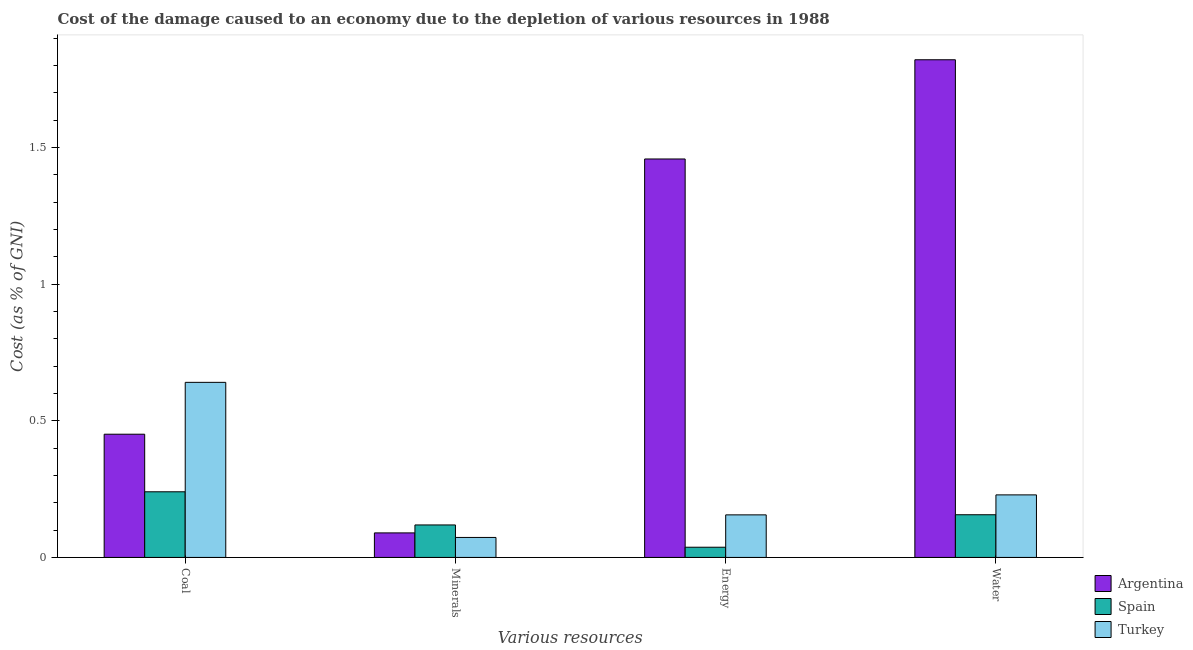Are the number of bars per tick equal to the number of legend labels?
Make the answer very short. Yes. Are the number of bars on each tick of the X-axis equal?
Provide a succinct answer. Yes. What is the label of the 4th group of bars from the left?
Ensure brevity in your answer.  Water. What is the cost of damage due to depletion of energy in Argentina?
Provide a succinct answer. 1.46. Across all countries, what is the maximum cost of damage due to depletion of energy?
Provide a short and direct response. 1.46. Across all countries, what is the minimum cost of damage due to depletion of water?
Provide a succinct answer. 0.16. In which country was the cost of damage due to depletion of energy maximum?
Keep it short and to the point. Argentina. What is the total cost of damage due to depletion of coal in the graph?
Provide a succinct answer. 1.33. What is the difference between the cost of damage due to depletion of coal in Turkey and that in Spain?
Ensure brevity in your answer.  0.4. What is the difference between the cost of damage due to depletion of water in Spain and the cost of damage due to depletion of energy in Turkey?
Give a very brief answer. 0. What is the average cost of damage due to depletion of minerals per country?
Keep it short and to the point. 0.09. What is the difference between the cost of damage due to depletion of coal and cost of damage due to depletion of water in Argentina?
Make the answer very short. -1.37. What is the ratio of the cost of damage due to depletion of energy in Argentina to that in Turkey?
Your answer should be very brief. 9.36. Is the cost of damage due to depletion of minerals in Turkey less than that in Spain?
Ensure brevity in your answer.  Yes. What is the difference between the highest and the second highest cost of damage due to depletion of coal?
Offer a terse response. 0.19. What is the difference between the highest and the lowest cost of damage due to depletion of minerals?
Offer a terse response. 0.05. Is the sum of the cost of damage due to depletion of energy in Spain and Argentina greater than the maximum cost of damage due to depletion of water across all countries?
Make the answer very short. No. Is it the case that in every country, the sum of the cost of damage due to depletion of minerals and cost of damage due to depletion of energy is greater than the sum of cost of damage due to depletion of coal and cost of damage due to depletion of water?
Offer a terse response. No. What does the 3rd bar from the right in Minerals represents?
Offer a very short reply. Argentina. How many bars are there?
Make the answer very short. 12. Does the graph contain any zero values?
Your answer should be compact. No. How are the legend labels stacked?
Offer a very short reply. Vertical. What is the title of the graph?
Your answer should be very brief. Cost of the damage caused to an economy due to the depletion of various resources in 1988 . Does "Venezuela" appear as one of the legend labels in the graph?
Offer a terse response. No. What is the label or title of the X-axis?
Keep it short and to the point. Various resources. What is the label or title of the Y-axis?
Offer a terse response. Cost (as % of GNI). What is the Cost (as % of GNI) in Argentina in Coal?
Offer a terse response. 0.45. What is the Cost (as % of GNI) in Spain in Coal?
Offer a terse response. 0.24. What is the Cost (as % of GNI) in Turkey in Coal?
Ensure brevity in your answer.  0.64. What is the Cost (as % of GNI) of Argentina in Minerals?
Make the answer very short. 0.09. What is the Cost (as % of GNI) of Spain in Minerals?
Offer a terse response. 0.12. What is the Cost (as % of GNI) of Turkey in Minerals?
Ensure brevity in your answer.  0.07. What is the Cost (as % of GNI) in Argentina in Energy?
Provide a short and direct response. 1.46. What is the Cost (as % of GNI) of Spain in Energy?
Provide a succinct answer. 0.04. What is the Cost (as % of GNI) in Turkey in Energy?
Your answer should be very brief. 0.16. What is the Cost (as % of GNI) in Argentina in Water?
Provide a short and direct response. 1.82. What is the Cost (as % of GNI) of Spain in Water?
Your response must be concise. 0.16. What is the Cost (as % of GNI) of Turkey in Water?
Keep it short and to the point. 0.23. Across all Various resources, what is the maximum Cost (as % of GNI) of Argentina?
Give a very brief answer. 1.82. Across all Various resources, what is the maximum Cost (as % of GNI) in Spain?
Provide a succinct answer. 0.24. Across all Various resources, what is the maximum Cost (as % of GNI) of Turkey?
Offer a very short reply. 0.64. Across all Various resources, what is the minimum Cost (as % of GNI) of Argentina?
Provide a succinct answer. 0.09. Across all Various resources, what is the minimum Cost (as % of GNI) of Spain?
Your response must be concise. 0.04. Across all Various resources, what is the minimum Cost (as % of GNI) in Turkey?
Give a very brief answer. 0.07. What is the total Cost (as % of GNI) of Argentina in the graph?
Give a very brief answer. 3.82. What is the total Cost (as % of GNI) in Spain in the graph?
Keep it short and to the point. 0.55. What is the total Cost (as % of GNI) of Turkey in the graph?
Provide a succinct answer. 1.1. What is the difference between the Cost (as % of GNI) in Argentina in Coal and that in Minerals?
Ensure brevity in your answer.  0.36. What is the difference between the Cost (as % of GNI) of Spain in Coal and that in Minerals?
Your answer should be compact. 0.12. What is the difference between the Cost (as % of GNI) in Turkey in Coal and that in Minerals?
Offer a very short reply. 0.57. What is the difference between the Cost (as % of GNI) in Argentina in Coal and that in Energy?
Your response must be concise. -1.01. What is the difference between the Cost (as % of GNI) in Spain in Coal and that in Energy?
Ensure brevity in your answer.  0.2. What is the difference between the Cost (as % of GNI) of Turkey in Coal and that in Energy?
Keep it short and to the point. 0.48. What is the difference between the Cost (as % of GNI) in Argentina in Coal and that in Water?
Provide a succinct answer. -1.37. What is the difference between the Cost (as % of GNI) in Spain in Coal and that in Water?
Your answer should be very brief. 0.08. What is the difference between the Cost (as % of GNI) of Turkey in Coal and that in Water?
Offer a terse response. 0.41. What is the difference between the Cost (as % of GNI) of Argentina in Minerals and that in Energy?
Offer a terse response. -1.37. What is the difference between the Cost (as % of GNI) of Spain in Minerals and that in Energy?
Offer a terse response. 0.08. What is the difference between the Cost (as % of GNI) in Turkey in Minerals and that in Energy?
Make the answer very short. -0.08. What is the difference between the Cost (as % of GNI) of Argentina in Minerals and that in Water?
Ensure brevity in your answer.  -1.73. What is the difference between the Cost (as % of GNI) of Spain in Minerals and that in Water?
Your answer should be compact. -0.04. What is the difference between the Cost (as % of GNI) in Turkey in Minerals and that in Water?
Ensure brevity in your answer.  -0.16. What is the difference between the Cost (as % of GNI) of Argentina in Energy and that in Water?
Make the answer very short. -0.36. What is the difference between the Cost (as % of GNI) in Spain in Energy and that in Water?
Offer a terse response. -0.12. What is the difference between the Cost (as % of GNI) in Turkey in Energy and that in Water?
Offer a terse response. -0.07. What is the difference between the Cost (as % of GNI) of Argentina in Coal and the Cost (as % of GNI) of Spain in Minerals?
Make the answer very short. 0.33. What is the difference between the Cost (as % of GNI) in Argentina in Coal and the Cost (as % of GNI) in Turkey in Minerals?
Your answer should be compact. 0.38. What is the difference between the Cost (as % of GNI) in Spain in Coal and the Cost (as % of GNI) in Turkey in Minerals?
Your response must be concise. 0.17. What is the difference between the Cost (as % of GNI) of Argentina in Coal and the Cost (as % of GNI) of Spain in Energy?
Provide a succinct answer. 0.41. What is the difference between the Cost (as % of GNI) in Argentina in Coal and the Cost (as % of GNI) in Turkey in Energy?
Your answer should be compact. 0.3. What is the difference between the Cost (as % of GNI) in Spain in Coal and the Cost (as % of GNI) in Turkey in Energy?
Provide a succinct answer. 0.08. What is the difference between the Cost (as % of GNI) of Argentina in Coal and the Cost (as % of GNI) of Spain in Water?
Provide a short and direct response. 0.29. What is the difference between the Cost (as % of GNI) in Argentina in Coal and the Cost (as % of GNI) in Turkey in Water?
Provide a succinct answer. 0.22. What is the difference between the Cost (as % of GNI) of Spain in Coal and the Cost (as % of GNI) of Turkey in Water?
Give a very brief answer. 0.01. What is the difference between the Cost (as % of GNI) in Argentina in Minerals and the Cost (as % of GNI) in Spain in Energy?
Give a very brief answer. 0.05. What is the difference between the Cost (as % of GNI) of Argentina in Minerals and the Cost (as % of GNI) of Turkey in Energy?
Your response must be concise. -0.07. What is the difference between the Cost (as % of GNI) of Spain in Minerals and the Cost (as % of GNI) of Turkey in Energy?
Your response must be concise. -0.04. What is the difference between the Cost (as % of GNI) of Argentina in Minerals and the Cost (as % of GNI) of Spain in Water?
Keep it short and to the point. -0.07. What is the difference between the Cost (as % of GNI) in Argentina in Minerals and the Cost (as % of GNI) in Turkey in Water?
Your answer should be very brief. -0.14. What is the difference between the Cost (as % of GNI) in Spain in Minerals and the Cost (as % of GNI) in Turkey in Water?
Keep it short and to the point. -0.11. What is the difference between the Cost (as % of GNI) of Argentina in Energy and the Cost (as % of GNI) of Spain in Water?
Your answer should be compact. 1.3. What is the difference between the Cost (as % of GNI) in Argentina in Energy and the Cost (as % of GNI) in Turkey in Water?
Your answer should be compact. 1.23. What is the difference between the Cost (as % of GNI) in Spain in Energy and the Cost (as % of GNI) in Turkey in Water?
Your response must be concise. -0.19. What is the average Cost (as % of GNI) of Argentina per Various resources?
Keep it short and to the point. 0.95. What is the average Cost (as % of GNI) of Spain per Various resources?
Provide a succinct answer. 0.14. What is the average Cost (as % of GNI) in Turkey per Various resources?
Ensure brevity in your answer.  0.27. What is the difference between the Cost (as % of GNI) of Argentina and Cost (as % of GNI) of Spain in Coal?
Your answer should be very brief. 0.21. What is the difference between the Cost (as % of GNI) of Argentina and Cost (as % of GNI) of Turkey in Coal?
Your answer should be compact. -0.19. What is the difference between the Cost (as % of GNI) of Spain and Cost (as % of GNI) of Turkey in Coal?
Your answer should be compact. -0.4. What is the difference between the Cost (as % of GNI) in Argentina and Cost (as % of GNI) in Spain in Minerals?
Make the answer very short. -0.03. What is the difference between the Cost (as % of GNI) in Argentina and Cost (as % of GNI) in Turkey in Minerals?
Your response must be concise. 0.02. What is the difference between the Cost (as % of GNI) in Spain and Cost (as % of GNI) in Turkey in Minerals?
Provide a succinct answer. 0.05. What is the difference between the Cost (as % of GNI) of Argentina and Cost (as % of GNI) of Spain in Energy?
Make the answer very short. 1.42. What is the difference between the Cost (as % of GNI) in Argentina and Cost (as % of GNI) in Turkey in Energy?
Make the answer very short. 1.3. What is the difference between the Cost (as % of GNI) in Spain and Cost (as % of GNI) in Turkey in Energy?
Offer a very short reply. -0.12. What is the difference between the Cost (as % of GNI) of Argentina and Cost (as % of GNI) of Spain in Water?
Your answer should be compact. 1.67. What is the difference between the Cost (as % of GNI) of Argentina and Cost (as % of GNI) of Turkey in Water?
Your answer should be compact. 1.59. What is the difference between the Cost (as % of GNI) of Spain and Cost (as % of GNI) of Turkey in Water?
Give a very brief answer. -0.07. What is the ratio of the Cost (as % of GNI) in Argentina in Coal to that in Minerals?
Offer a very short reply. 5.02. What is the ratio of the Cost (as % of GNI) of Spain in Coal to that in Minerals?
Make the answer very short. 2.02. What is the ratio of the Cost (as % of GNI) of Turkey in Coal to that in Minerals?
Make the answer very short. 8.76. What is the ratio of the Cost (as % of GNI) of Argentina in Coal to that in Energy?
Your answer should be very brief. 0.31. What is the ratio of the Cost (as % of GNI) of Spain in Coal to that in Energy?
Offer a terse response. 6.43. What is the ratio of the Cost (as % of GNI) of Turkey in Coal to that in Energy?
Make the answer very short. 4.11. What is the ratio of the Cost (as % of GNI) in Argentina in Coal to that in Water?
Keep it short and to the point. 0.25. What is the ratio of the Cost (as % of GNI) of Spain in Coal to that in Water?
Ensure brevity in your answer.  1.54. What is the ratio of the Cost (as % of GNI) of Turkey in Coal to that in Water?
Make the answer very short. 2.8. What is the ratio of the Cost (as % of GNI) of Argentina in Minerals to that in Energy?
Offer a terse response. 0.06. What is the ratio of the Cost (as % of GNI) of Spain in Minerals to that in Energy?
Provide a short and direct response. 3.18. What is the ratio of the Cost (as % of GNI) in Turkey in Minerals to that in Energy?
Your answer should be very brief. 0.47. What is the ratio of the Cost (as % of GNI) in Argentina in Minerals to that in Water?
Offer a terse response. 0.05. What is the ratio of the Cost (as % of GNI) in Spain in Minerals to that in Water?
Ensure brevity in your answer.  0.76. What is the ratio of the Cost (as % of GNI) in Turkey in Minerals to that in Water?
Give a very brief answer. 0.32. What is the ratio of the Cost (as % of GNI) in Argentina in Energy to that in Water?
Ensure brevity in your answer.  0.8. What is the ratio of the Cost (as % of GNI) in Spain in Energy to that in Water?
Your answer should be very brief. 0.24. What is the ratio of the Cost (as % of GNI) in Turkey in Energy to that in Water?
Your answer should be very brief. 0.68. What is the difference between the highest and the second highest Cost (as % of GNI) of Argentina?
Give a very brief answer. 0.36. What is the difference between the highest and the second highest Cost (as % of GNI) in Spain?
Give a very brief answer. 0.08. What is the difference between the highest and the second highest Cost (as % of GNI) in Turkey?
Make the answer very short. 0.41. What is the difference between the highest and the lowest Cost (as % of GNI) in Argentina?
Provide a succinct answer. 1.73. What is the difference between the highest and the lowest Cost (as % of GNI) of Spain?
Ensure brevity in your answer.  0.2. What is the difference between the highest and the lowest Cost (as % of GNI) in Turkey?
Offer a very short reply. 0.57. 